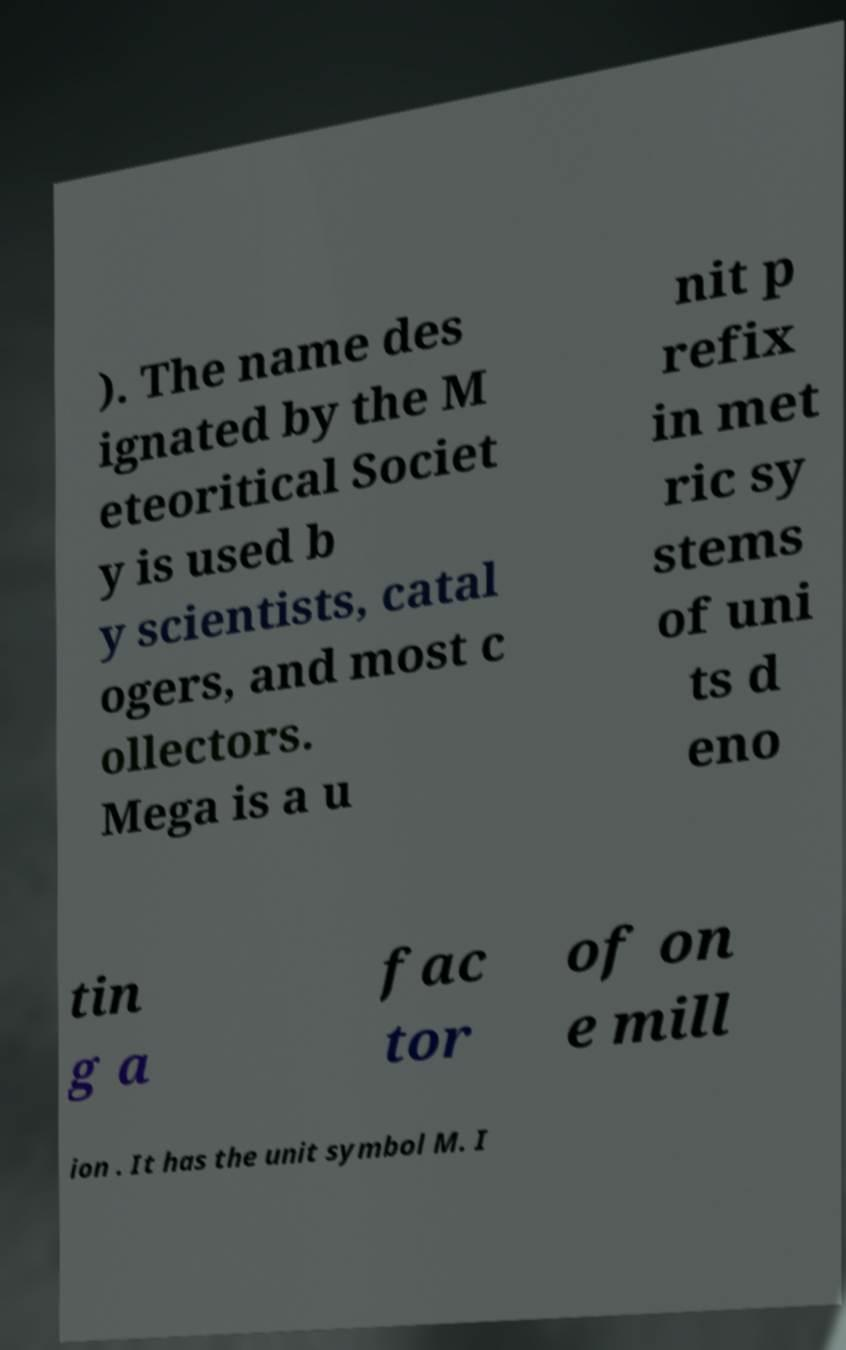Please identify and transcribe the text found in this image. ). The name des ignated by the M eteoritical Societ y is used b y scientists, catal ogers, and most c ollectors. Mega is a u nit p refix in met ric sy stems of uni ts d eno tin g a fac tor of on e mill ion . It has the unit symbol M. I 